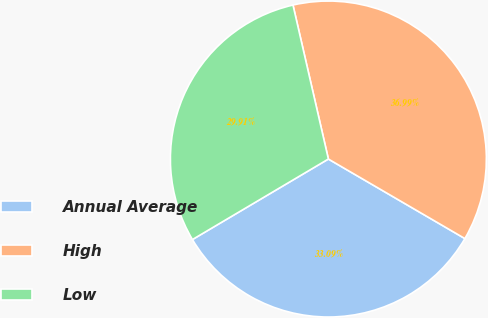<chart> <loc_0><loc_0><loc_500><loc_500><pie_chart><fcel>Annual Average<fcel>High<fcel>Low<nl><fcel>33.09%<fcel>36.99%<fcel>29.91%<nl></chart> 